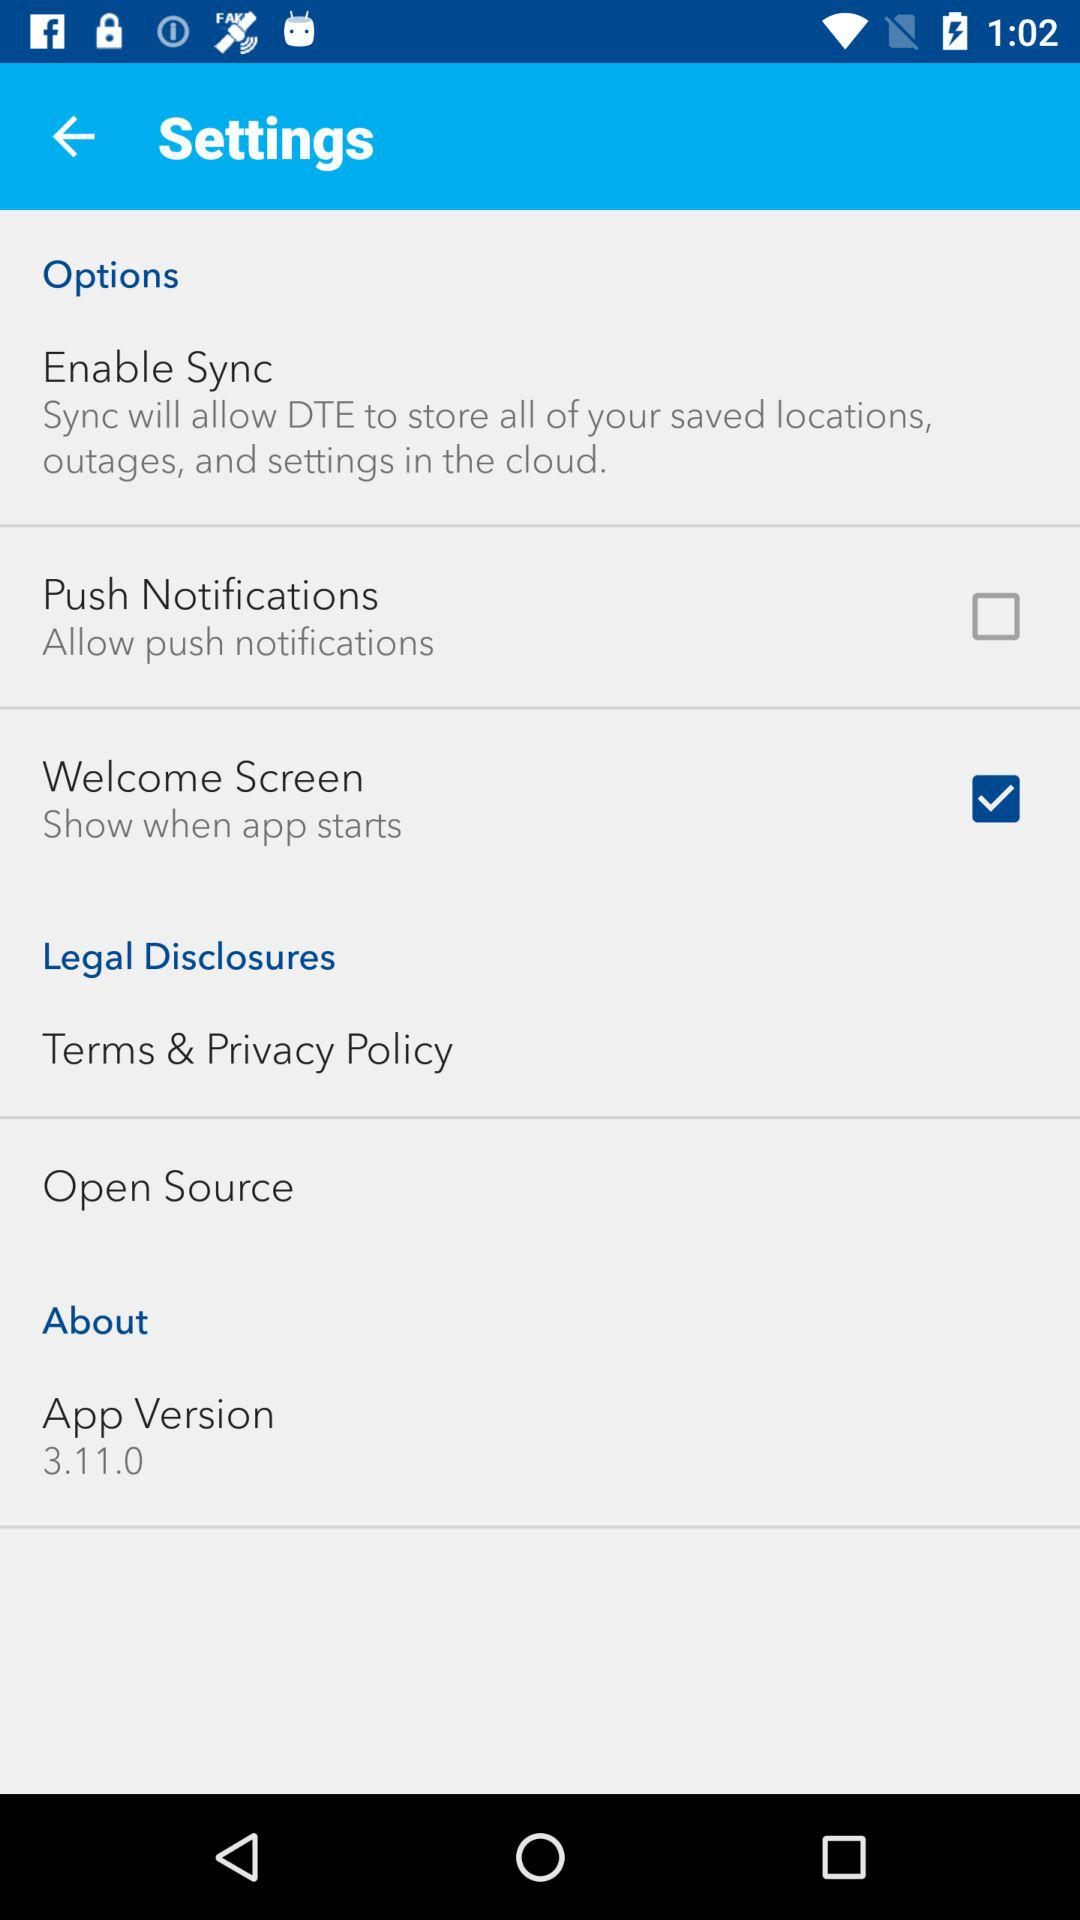What is the status of "Push Notifications"? The status of "Push Notifications" is "off". 